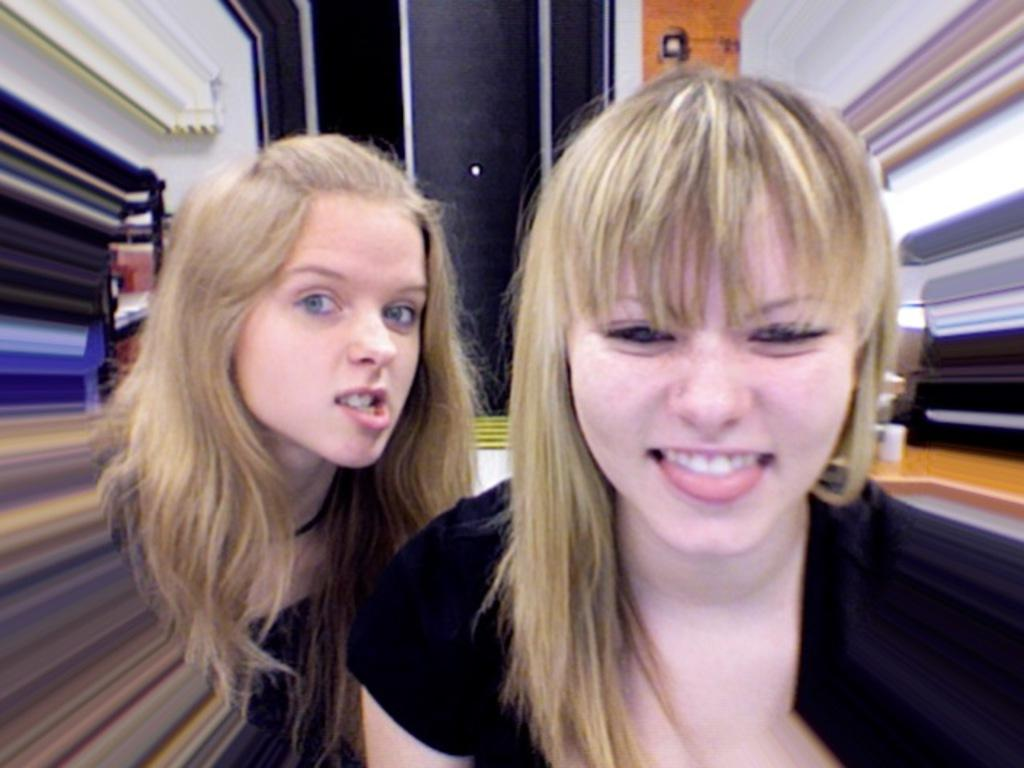How many people are in the image? There are a few people in the image. What can be seen on the left side of the image? There are objects on the left side of the image. What can be seen on the right side of the image? There are objects on the right side of the image. What is visible behind the people and objects in the image? The background of the image is visible. What type of club do the brothers use in the image? There is no mention of brothers or a club in the image. 